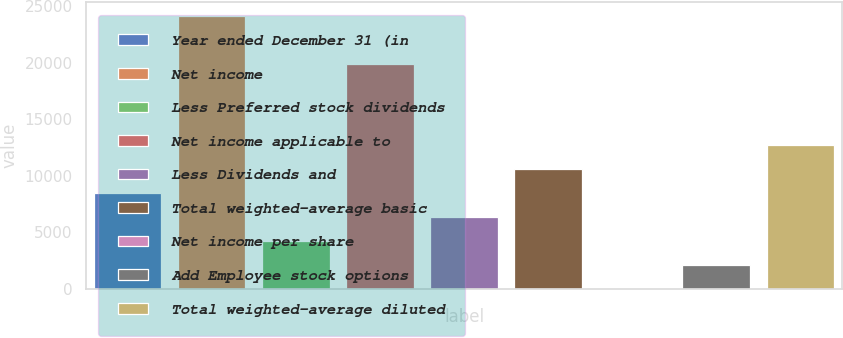<chart> <loc_0><loc_0><loc_500><loc_500><bar_chart><fcel>Year ended December 31 (in<fcel>Net income<fcel>Less Preferred stock dividends<fcel>Net income applicable to<fcel>Less Dividends and<fcel>Total weighted-average basic<fcel>Net income per share<fcel>Add Employee stock options<fcel>Total weighted-average diluted<nl><fcel>8516.74<fcel>24132.8<fcel>4260.98<fcel>19877<fcel>6388.86<fcel>10644.6<fcel>5.22<fcel>2133.1<fcel>12772.5<nl></chart> 